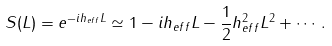Convert formula to latex. <formula><loc_0><loc_0><loc_500><loc_500>S ( L ) = e ^ { - i h _ { e f f } L } \simeq 1 - i h _ { e f f } L - { \frac { 1 } { 2 } } h _ { e f f } ^ { 2 } L ^ { 2 } + \cdots .</formula> 